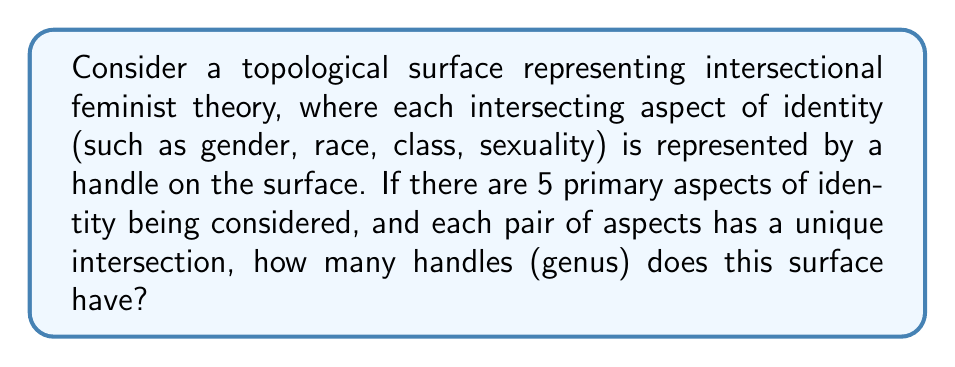Show me your answer to this math problem. To solve this problem, we need to consider both the individual aspects of identity and their intersections. Let's approach this step-by-step:

1. Individual aspects:
   We are given 5 primary aspects of identity. Each of these contributes one handle to the surface.
   Number of handles from individual aspects = 5

2. Intersections:
   We need to calculate the number of unique pairs among 5 aspects. This is given by the combination formula:
   
   $$\binom{5}{2} = \frac{5!}{2!(5-2)!} = \frac{5 \cdot 4}{2 \cdot 1} = 10$$

   Each of these intersections contributes an additional handle.
   Number of handles from intersections = 10

3. Total number of handles:
   The genus of the surface is the sum of handles from individual aspects and their intersections.
   
   $$\text{Genus} = 5 + 10 = 15$$

This surface can be visualized as a sphere with 15 handles, representing a complex, interconnected model of intersectional feminist theory where each aspect of identity and its interactions with others are represented topologically.

[asy]
import three;

size(200);
currentprojection=perspective(6,3,2);

// Draw a sphere
triple center = (0,0,0);
real radius = 1;
surface sphere = surface(sphere(center, radius));
draw(sphere, lightgray);

// Draw some handles (simplified representation)
for (int i = 0; i < 5; ++i) {
  real ang = 2pi * i / 5;
  triple p1 = (cos(ang), sin(ang), 0.5);
  triple p2 = (cos(ang), sin(ang), -0.5);
  draw(p1--p2, red+linewidth(2));
}

// Draw some intersection handles
for (int i = 0; i < 5; ++i) {
  for (int j = i+1; j < 5; ++j) {
    real ang1 = 2pi * i / 5;
    real ang2 = 2pi * j / 5;
    triple p1 = (cos(ang1), sin(ang1), 0);
    triple p2 = (cos(ang2), sin(ang2), 0);
    draw(p1--p2, blue+linewidth(2));
  }
}
[/asy]
Answer: The genus of the surface representing intersectional feminist theory with 5 primary aspects of identity is 15. 